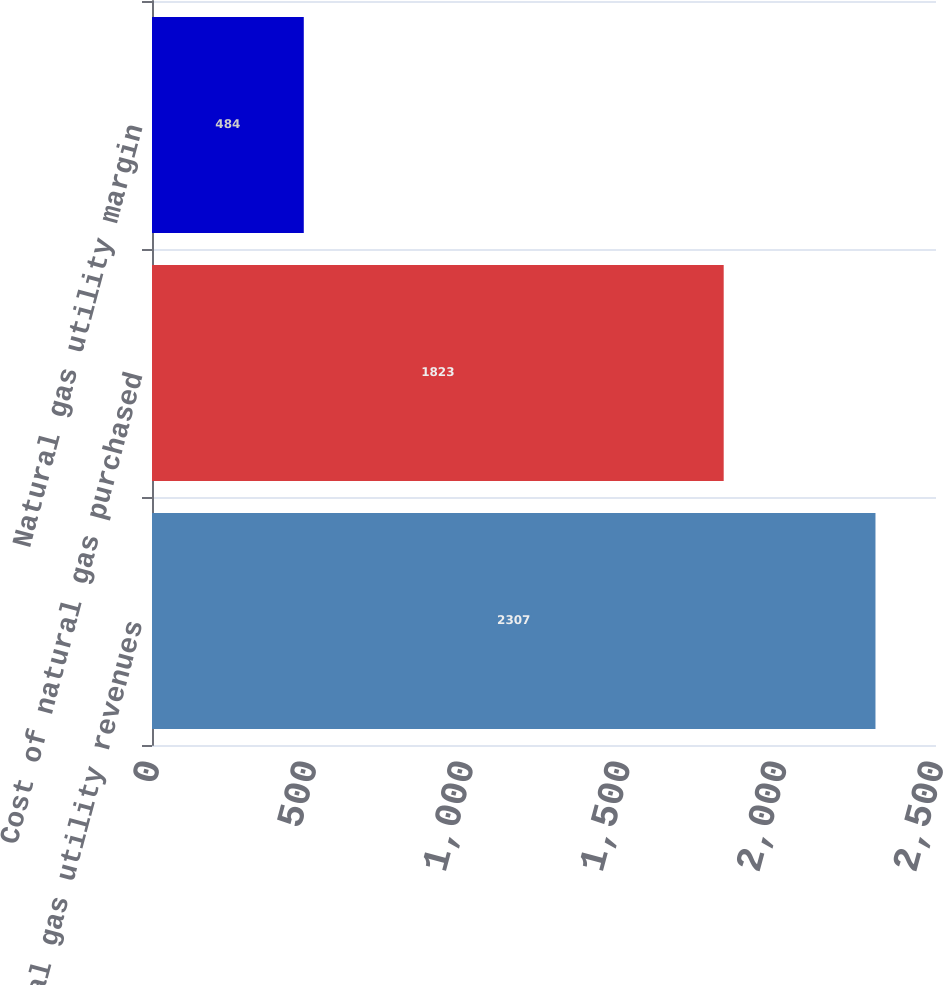Convert chart to OTSL. <chart><loc_0><loc_0><loc_500><loc_500><bar_chart><fcel>Natural gas utility revenues<fcel>Cost of natural gas purchased<fcel>Natural gas utility margin<nl><fcel>2307<fcel>1823<fcel>484<nl></chart> 